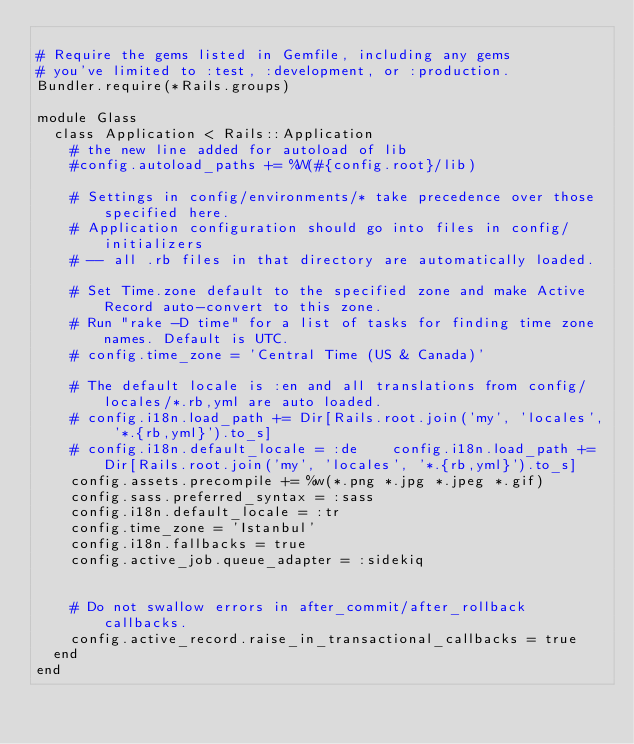Convert code to text. <code><loc_0><loc_0><loc_500><loc_500><_Ruby_>
# Require the gems listed in Gemfile, including any gems
# you've limited to :test, :development, or :production.
Bundler.require(*Rails.groups)

module Glass
  class Application < Rails::Application
    # the new line added for autoload of lib
    #config.autoload_paths += %W(#{config.root}/lib)

    # Settings in config/environments/* take precedence over those specified here.
    # Application configuration should go into files in config/initializers
    # -- all .rb files in that directory are automatically loaded.

    # Set Time.zone default to the specified zone and make Active Record auto-convert to this zone.
    # Run "rake -D time" for a list of tasks for finding time zone names. Default is UTC.
    # config.time_zone = 'Central Time (US & Canada)'

    # The default locale is :en and all translations from config/locales/*.rb,yml are auto loaded.
    # config.i18n.load_path += Dir[Rails.root.join('my', 'locales', '*.{rb,yml}').to_s]
    # config.i18n.default_locale = :de    config.i18n.load_path += Dir[Rails.root.join('my', 'locales', '*.{rb,yml}').to_s]
    config.assets.precompile += %w(*.png *.jpg *.jpeg *.gif)
    config.sass.preferred_syntax = :sass
    config.i18n.default_locale = :tr
    config.time_zone = 'Istanbul'
    config.i18n.fallbacks = true
    config.active_job.queue_adapter = :sidekiq


    # Do not swallow errors in after_commit/after_rollback callbacks.
    config.active_record.raise_in_transactional_callbacks = true
  end
end
</code> 